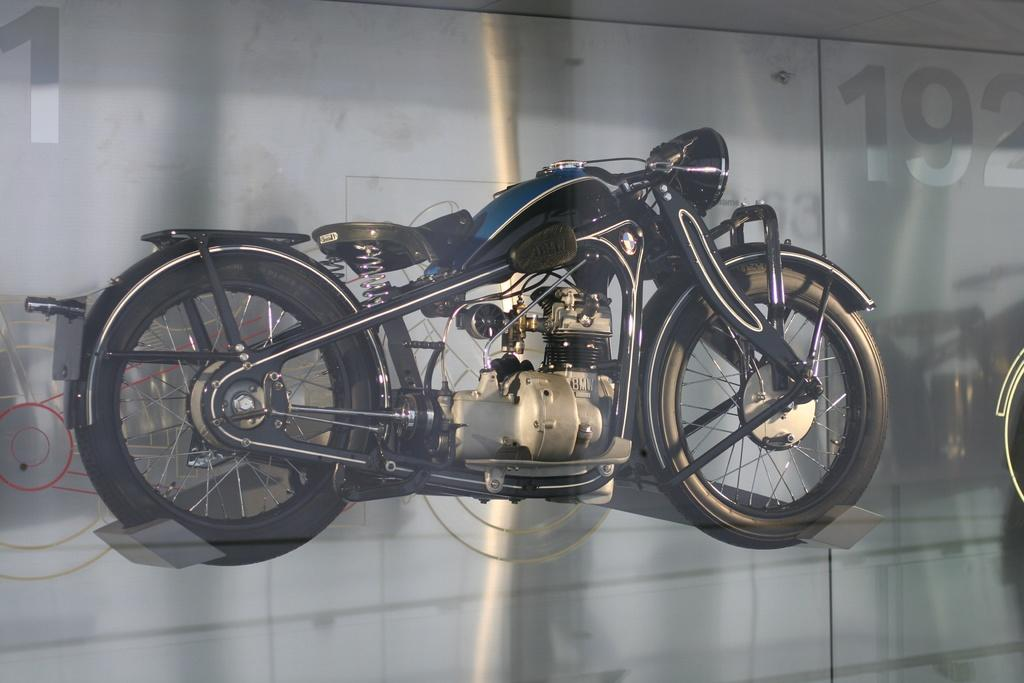What is the main subject in the center of the image? There is a bike in the center of the image. What is located behind the bike? There is glass behind the bike. Where can a number be found in the image? There is a number on the right side of the image. How many apples are hanging from the bike in the image? There are no apples present in the image, so it is not possible to determine how many might be hanging from the bike. 